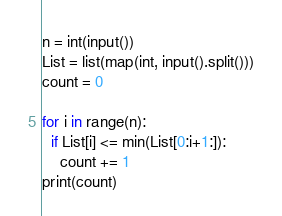<code> <loc_0><loc_0><loc_500><loc_500><_Python_>n = int(input())
List = list(map(int, input().split()))
count = 0

for i in range(n):
  if List[i] <= min(List[0:i+1:]):
    count += 1
print(count)</code> 